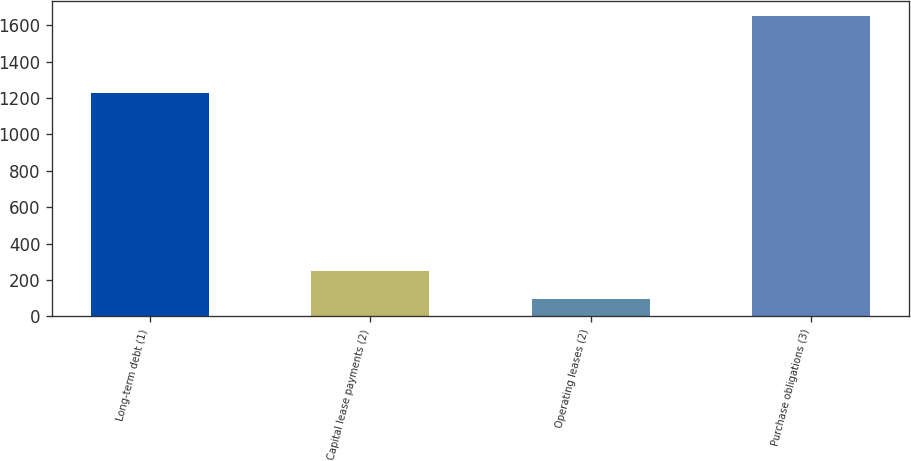Convert chart. <chart><loc_0><loc_0><loc_500><loc_500><bar_chart><fcel>Long-term debt (1)<fcel>Capital lease payments (2)<fcel>Operating leases (2)<fcel>Purchase obligations (3)<nl><fcel>1227<fcel>250.4<fcel>95<fcel>1649<nl></chart> 